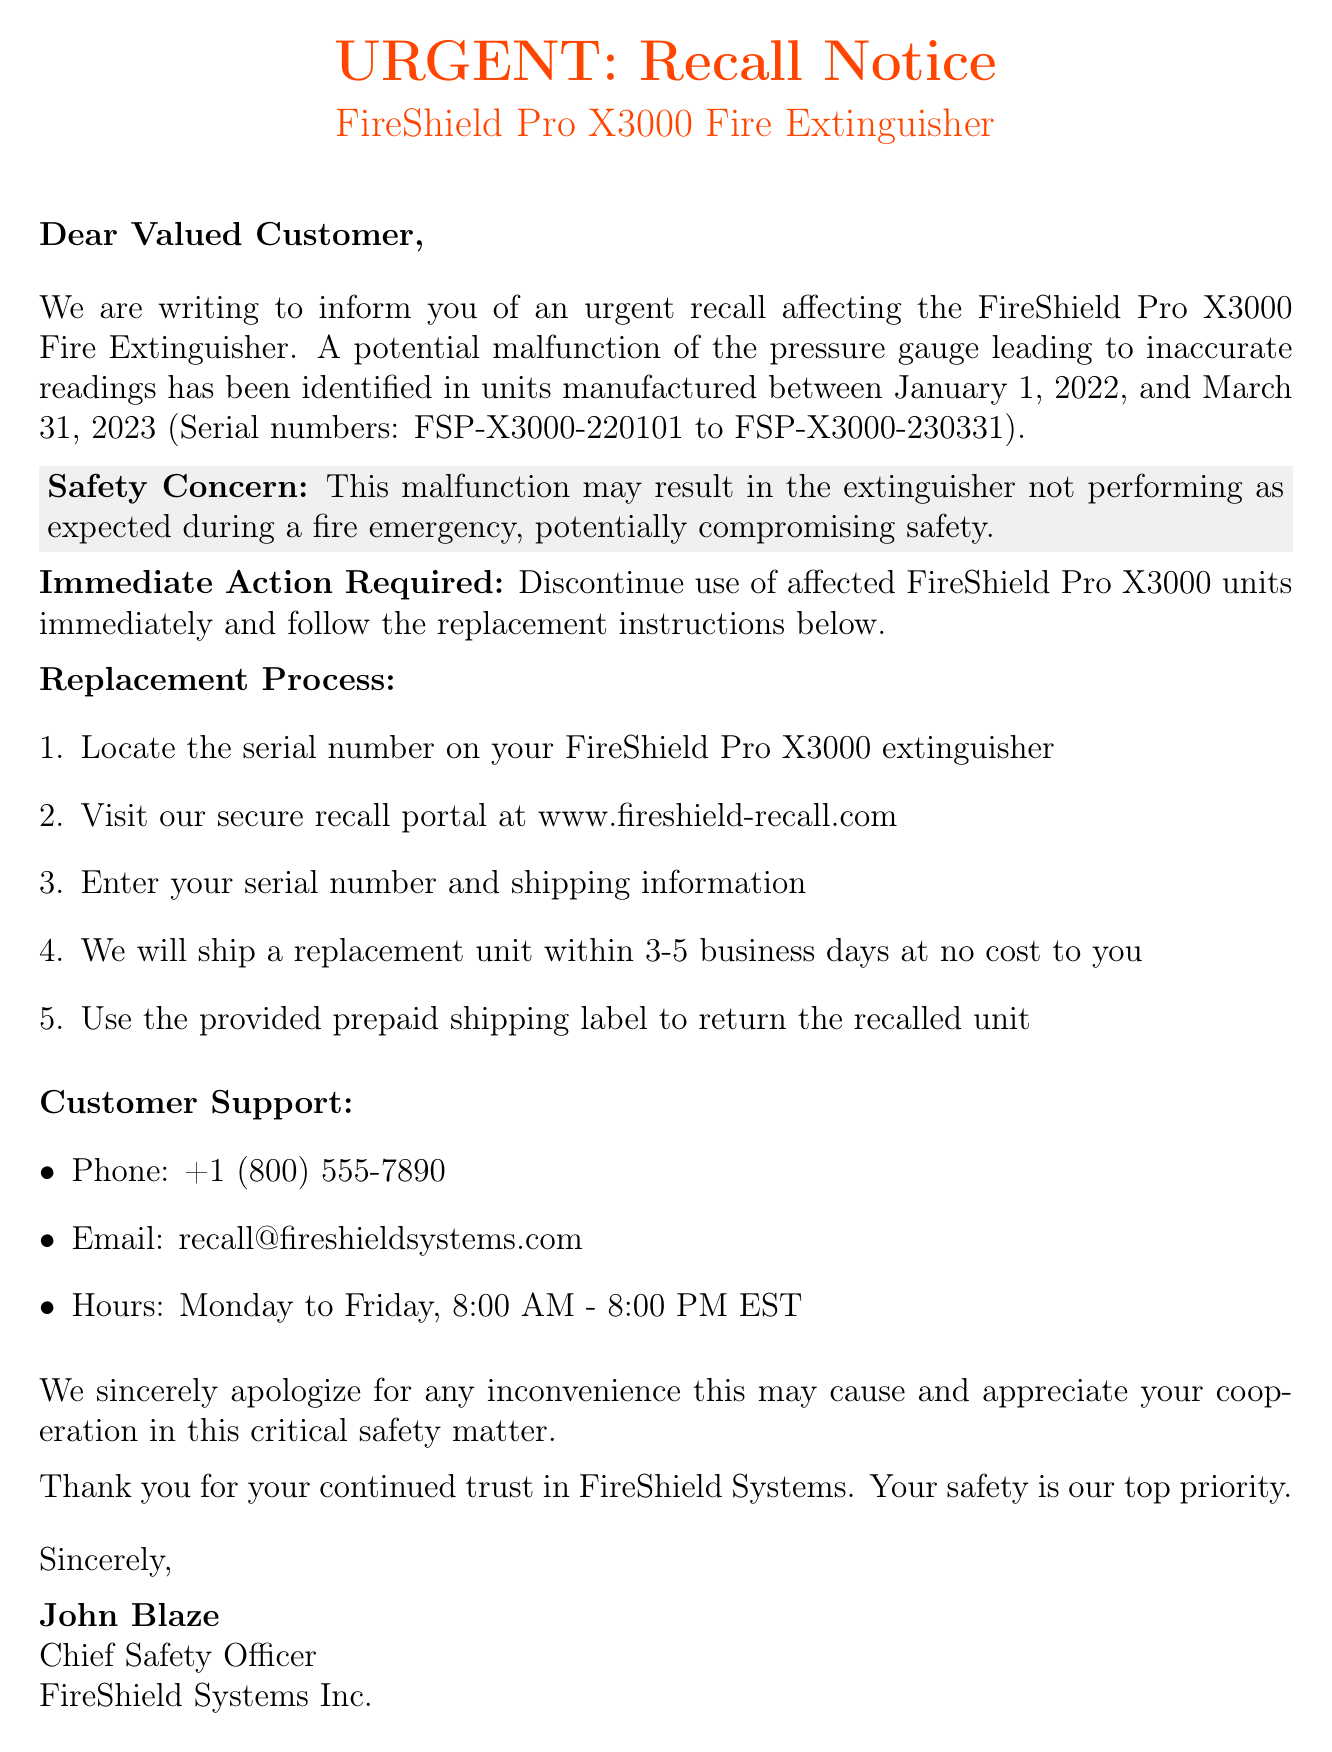What is the product being recalled? The document specifies that the product being recalled is the FireShield Pro X3000 Fire Extinguisher.
Answer: FireShield Pro X3000 Fire Extinguisher What is the issue with the affected units? The document states that there is a potential malfunction of the pressure gauge leading to inaccurate readings.
Answer: Potential malfunction of the pressure gauge What is the date range of the affected models? The document mentions that all units manufactured between January 1, 2022, and March 31, 2023 are affected.
Answer: January 1, 2022, to March 31, 2023 What should customers do immediately? The document instructs customers to discontinue use of affected FireShield Pro X3000 units immediately.
Answer: Discontinue use immediately How long will it take to receive a replacement unit? According to the document, customers will receive a replacement unit within 3-5 business days.
Answer: 3-5 business days What is the contact phone number for customer support? The document provides a customer support phone number, which is essential for inquiries.
Answer: +1 (800) 555-7890 Who signed the recall notice? The document specifies the name of the person who signed it, which is relevant for authenticity.
Answer: John Blaze What may happen if the malfunction occurs? The document suggests that the malfunction may affect the performance during a fire emergency, indicating its seriousness.
Answer: Compromising safety What is the web address for the recall portal? The document includes a secure recall portal for replacement processes, which is crucial for affected customers.
Answer: www.fireshield-recall.com 